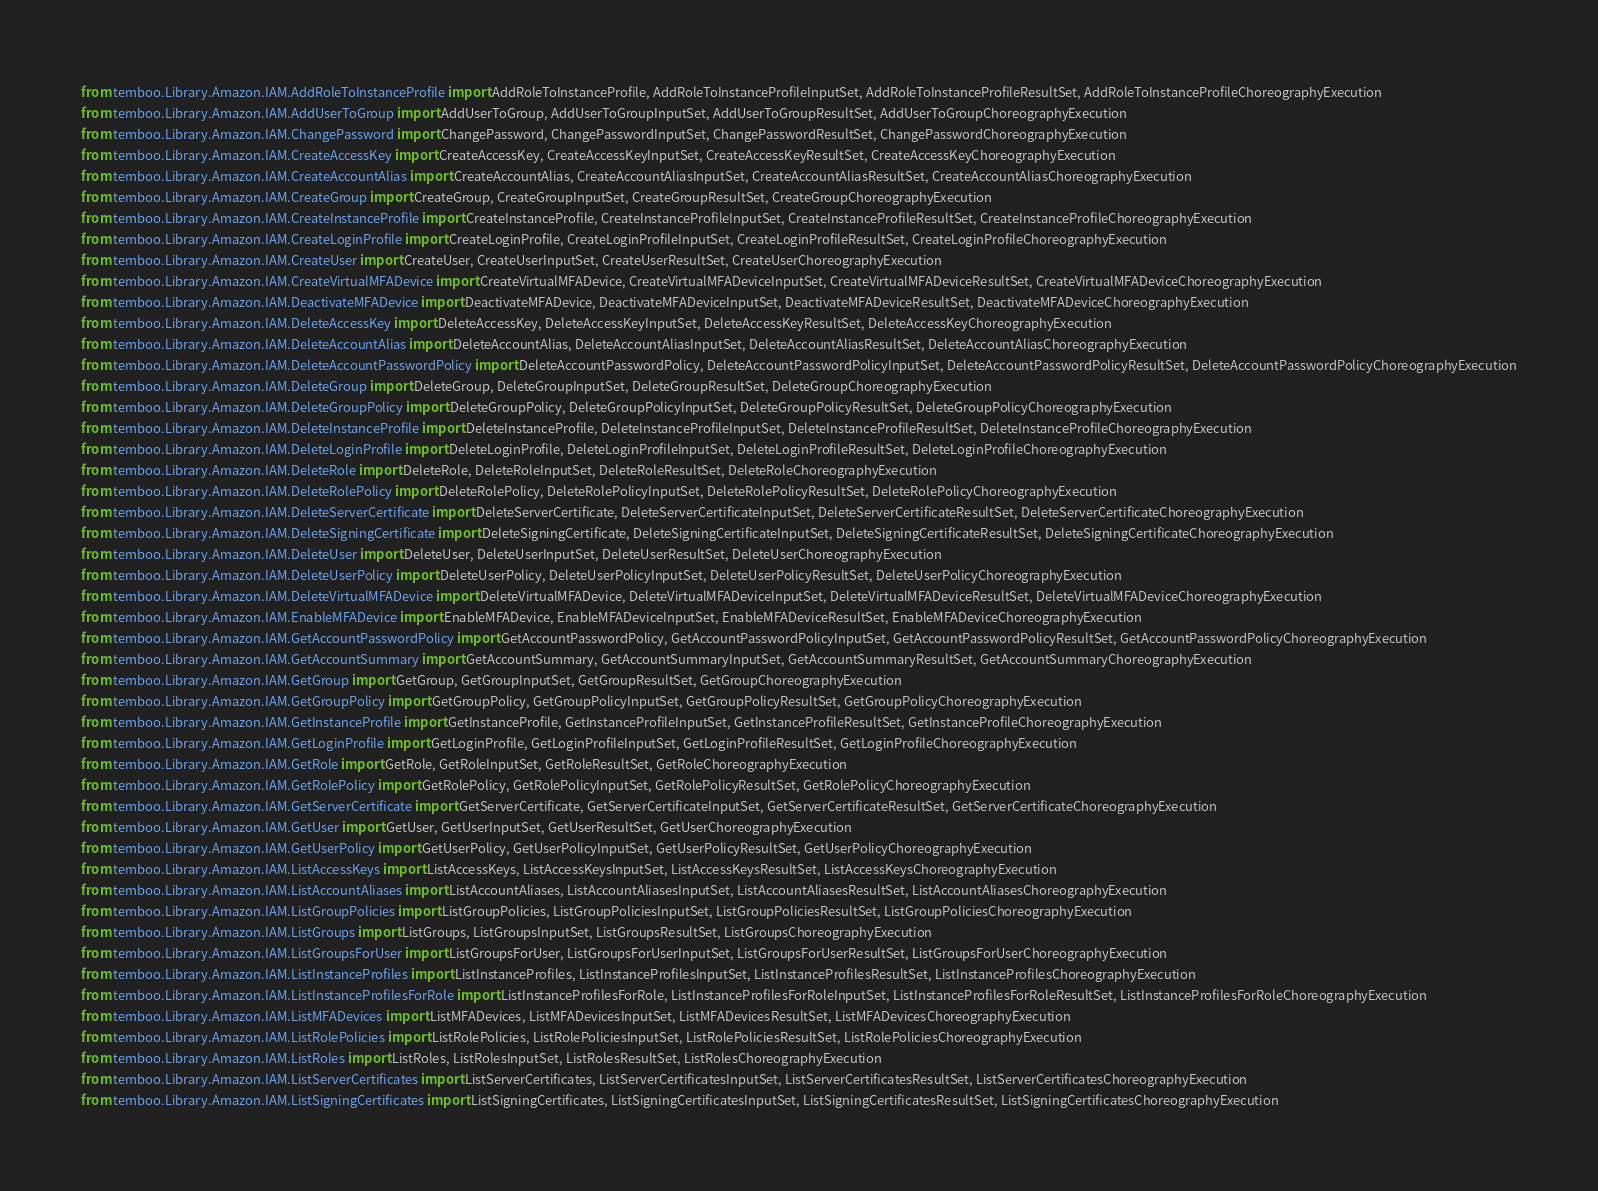<code> <loc_0><loc_0><loc_500><loc_500><_Python_>from temboo.Library.Amazon.IAM.AddRoleToInstanceProfile import AddRoleToInstanceProfile, AddRoleToInstanceProfileInputSet, AddRoleToInstanceProfileResultSet, AddRoleToInstanceProfileChoreographyExecution
from temboo.Library.Amazon.IAM.AddUserToGroup import AddUserToGroup, AddUserToGroupInputSet, AddUserToGroupResultSet, AddUserToGroupChoreographyExecution
from temboo.Library.Amazon.IAM.ChangePassword import ChangePassword, ChangePasswordInputSet, ChangePasswordResultSet, ChangePasswordChoreographyExecution
from temboo.Library.Amazon.IAM.CreateAccessKey import CreateAccessKey, CreateAccessKeyInputSet, CreateAccessKeyResultSet, CreateAccessKeyChoreographyExecution
from temboo.Library.Amazon.IAM.CreateAccountAlias import CreateAccountAlias, CreateAccountAliasInputSet, CreateAccountAliasResultSet, CreateAccountAliasChoreographyExecution
from temboo.Library.Amazon.IAM.CreateGroup import CreateGroup, CreateGroupInputSet, CreateGroupResultSet, CreateGroupChoreographyExecution
from temboo.Library.Amazon.IAM.CreateInstanceProfile import CreateInstanceProfile, CreateInstanceProfileInputSet, CreateInstanceProfileResultSet, CreateInstanceProfileChoreographyExecution
from temboo.Library.Amazon.IAM.CreateLoginProfile import CreateLoginProfile, CreateLoginProfileInputSet, CreateLoginProfileResultSet, CreateLoginProfileChoreographyExecution
from temboo.Library.Amazon.IAM.CreateUser import CreateUser, CreateUserInputSet, CreateUserResultSet, CreateUserChoreographyExecution
from temboo.Library.Amazon.IAM.CreateVirtualMFADevice import CreateVirtualMFADevice, CreateVirtualMFADeviceInputSet, CreateVirtualMFADeviceResultSet, CreateVirtualMFADeviceChoreographyExecution
from temboo.Library.Amazon.IAM.DeactivateMFADevice import DeactivateMFADevice, DeactivateMFADeviceInputSet, DeactivateMFADeviceResultSet, DeactivateMFADeviceChoreographyExecution
from temboo.Library.Amazon.IAM.DeleteAccessKey import DeleteAccessKey, DeleteAccessKeyInputSet, DeleteAccessKeyResultSet, DeleteAccessKeyChoreographyExecution
from temboo.Library.Amazon.IAM.DeleteAccountAlias import DeleteAccountAlias, DeleteAccountAliasInputSet, DeleteAccountAliasResultSet, DeleteAccountAliasChoreographyExecution
from temboo.Library.Amazon.IAM.DeleteAccountPasswordPolicy import DeleteAccountPasswordPolicy, DeleteAccountPasswordPolicyInputSet, DeleteAccountPasswordPolicyResultSet, DeleteAccountPasswordPolicyChoreographyExecution
from temboo.Library.Amazon.IAM.DeleteGroup import DeleteGroup, DeleteGroupInputSet, DeleteGroupResultSet, DeleteGroupChoreographyExecution
from temboo.Library.Amazon.IAM.DeleteGroupPolicy import DeleteGroupPolicy, DeleteGroupPolicyInputSet, DeleteGroupPolicyResultSet, DeleteGroupPolicyChoreographyExecution
from temboo.Library.Amazon.IAM.DeleteInstanceProfile import DeleteInstanceProfile, DeleteInstanceProfileInputSet, DeleteInstanceProfileResultSet, DeleteInstanceProfileChoreographyExecution
from temboo.Library.Amazon.IAM.DeleteLoginProfile import DeleteLoginProfile, DeleteLoginProfileInputSet, DeleteLoginProfileResultSet, DeleteLoginProfileChoreographyExecution
from temboo.Library.Amazon.IAM.DeleteRole import DeleteRole, DeleteRoleInputSet, DeleteRoleResultSet, DeleteRoleChoreographyExecution
from temboo.Library.Amazon.IAM.DeleteRolePolicy import DeleteRolePolicy, DeleteRolePolicyInputSet, DeleteRolePolicyResultSet, DeleteRolePolicyChoreographyExecution
from temboo.Library.Amazon.IAM.DeleteServerCertificate import DeleteServerCertificate, DeleteServerCertificateInputSet, DeleteServerCertificateResultSet, DeleteServerCertificateChoreographyExecution
from temboo.Library.Amazon.IAM.DeleteSigningCertificate import DeleteSigningCertificate, DeleteSigningCertificateInputSet, DeleteSigningCertificateResultSet, DeleteSigningCertificateChoreographyExecution
from temboo.Library.Amazon.IAM.DeleteUser import DeleteUser, DeleteUserInputSet, DeleteUserResultSet, DeleteUserChoreographyExecution
from temboo.Library.Amazon.IAM.DeleteUserPolicy import DeleteUserPolicy, DeleteUserPolicyInputSet, DeleteUserPolicyResultSet, DeleteUserPolicyChoreographyExecution
from temboo.Library.Amazon.IAM.DeleteVirtualMFADevice import DeleteVirtualMFADevice, DeleteVirtualMFADeviceInputSet, DeleteVirtualMFADeviceResultSet, DeleteVirtualMFADeviceChoreographyExecution
from temboo.Library.Amazon.IAM.EnableMFADevice import EnableMFADevice, EnableMFADeviceInputSet, EnableMFADeviceResultSet, EnableMFADeviceChoreographyExecution
from temboo.Library.Amazon.IAM.GetAccountPasswordPolicy import GetAccountPasswordPolicy, GetAccountPasswordPolicyInputSet, GetAccountPasswordPolicyResultSet, GetAccountPasswordPolicyChoreographyExecution
from temboo.Library.Amazon.IAM.GetAccountSummary import GetAccountSummary, GetAccountSummaryInputSet, GetAccountSummaryResultSet, GetAccountSummaryChoreographyExecution
from temboo.Library.Amazon.IAM.GetGroup import GetGroup, GetGroupInputSet, GetGroupResultSet, GetGroupChoreographyExecution
from temboo.Library.Amazon.IAM.GetGroupPolicy import GetGroupPolicy, GetGroupPolicyInputSet, GetGroupPolicyResultSet, GetGroupPolicyChoreographyExecution
from temboo.Library.Amazon.IAM.GetInstanceProfile import GetInstanceProfile, GetInstanceProfileInputSet, GetInstanceProfileResultSet, GetInstanceProfileChoreographyExecution
from temboo.Library.Amazon.IAM.GetLoginProfile import GetLoginProfile, GetLoginProfileInputSet, GetLoginProfileResultSet, GetLoginProfileChoreographyExecution
from temboo.Library.Amazon.IAM.GetRole import GetRole, GetRoleInputSet, GetRoleResultSet, GetRoleChoreographyExecution
from temboo.Library.Amazon.IAM.GetRolePolicy import GetRolePolicy, GetRolePolicyInputSet, GetRolePolicyResultSet, GetRolePolicyChoreographyExecution
from temboo.Library.Amazon.IAM.GetServerCertificate import GetServerCertificate, GetServerCertificateInputSet, GetServerCertificateResultSet, GetServerCertificateChoreographyExecution
from temboo.Library.Amazon.IAM.GetUser import GetUser, GetUserInputSet, GetUserResultSet, GetUserChoreographyExecution
from temboo.Library.Amazon.IAM.GetUserPolicy import GetUserPolicy, GetUserPolicyInputSet, GetUserPolicyResultSet, GetUserPolicyChoreographyExecution
from temboo.Library.Amazon.IAM.ListAccessKeys import ListAccessKeys, ListAccessKeysInputSet, ListAccessKeysResultSet, ListAccessKeysChoreographyExecution
from temboo.Library.Amazon.IAM.ListAccountAliases import ListAccountAliases, ListAccountAliasesInputSet, ListAccountAliasesResultSet, ListAccountAliasesChoreographyExecution
from temboo.Library.Amazon.IAM.ListGroupPolicies import ListGroupPolicies, ListGroupPoliciesInputSet, ListGroupPoliciesResultSet, ListGroupPoliciesChoreographyExecution
from temboo.Library.Amazon.IAM.ListGroups import ListGroups, ListGroupsInputSet, ListGroupsResultSet, ListGroupsChoreographyExecution
from temboo.Library.Amazon.IAM.ListGroupsForUser import ListGroupsForUser, ListGroupsForUserInputSet, ListGroupsForUserResultSet, ListGroupsForUserChoreographyExecution
from temboo.Library.Amazon.IAM.ListInstanceProfiles import ListInstanceProfiles, ListInstanceProfilesInputSet, ListInstanceProfilesResultSet, ListInstanceProfilesChoreographyExecution
from temboo.Library.Amazon.IAM.ListInstanceProfilesForRole import ListInstanceProfilesForRole, ListInstanceProfilesForRoleInputSet, ListInstanceProfilesForRoleResultSet, ListInstanceProfilesForRoleChoreographyExecution
from temboo.Library.Amazon.IAM.ListMFADevices import ListMFADevices, ListMFADevicesInputSet, ListMFADevicesResultSet, ListMFADevicesChoreographyExecution
from temboo.Library.Amazon.IAM.ListRolePolicies import ListRolePolicies, ListRolePoliciesInputSet, ListRolePoliciesResultSet, ListRolePoliciesChoreographyExecution
from temboo.Library.Amazon.IAM.ListRoles import ListRoles, ListRolesInputSet, ListRolesResultSet, ListRolesChoreographyExecution
from temboo.Library.Amazon.IAM.ListServerCertificates import ListServerCertificates, ListServerCertificatesInputSet, ListServerCertificatesResultSet, ListServerCertificatesChoreographyExecution
from temboo.Library.Amazon.IAM.ListSigningCertificates import ListSigningCertificates, ListSigningCertificatesInputSet, ListSigningCertificatesResultSet, ListSigningCertificatesChoreographyExecution</code> 